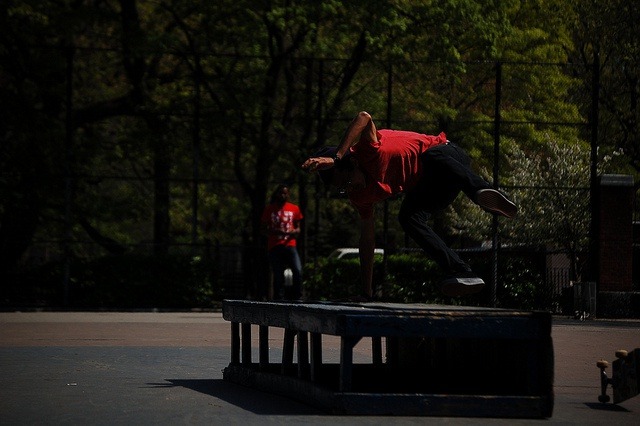Describe the objects in this image and their specific colors. I can see people in black, maroon, and brown tones, people in black, maroon, and brown tones, skateboard in black, maroon, and gray tones, and car in black, darkgray, gray, and darkgreen tones in this image. 